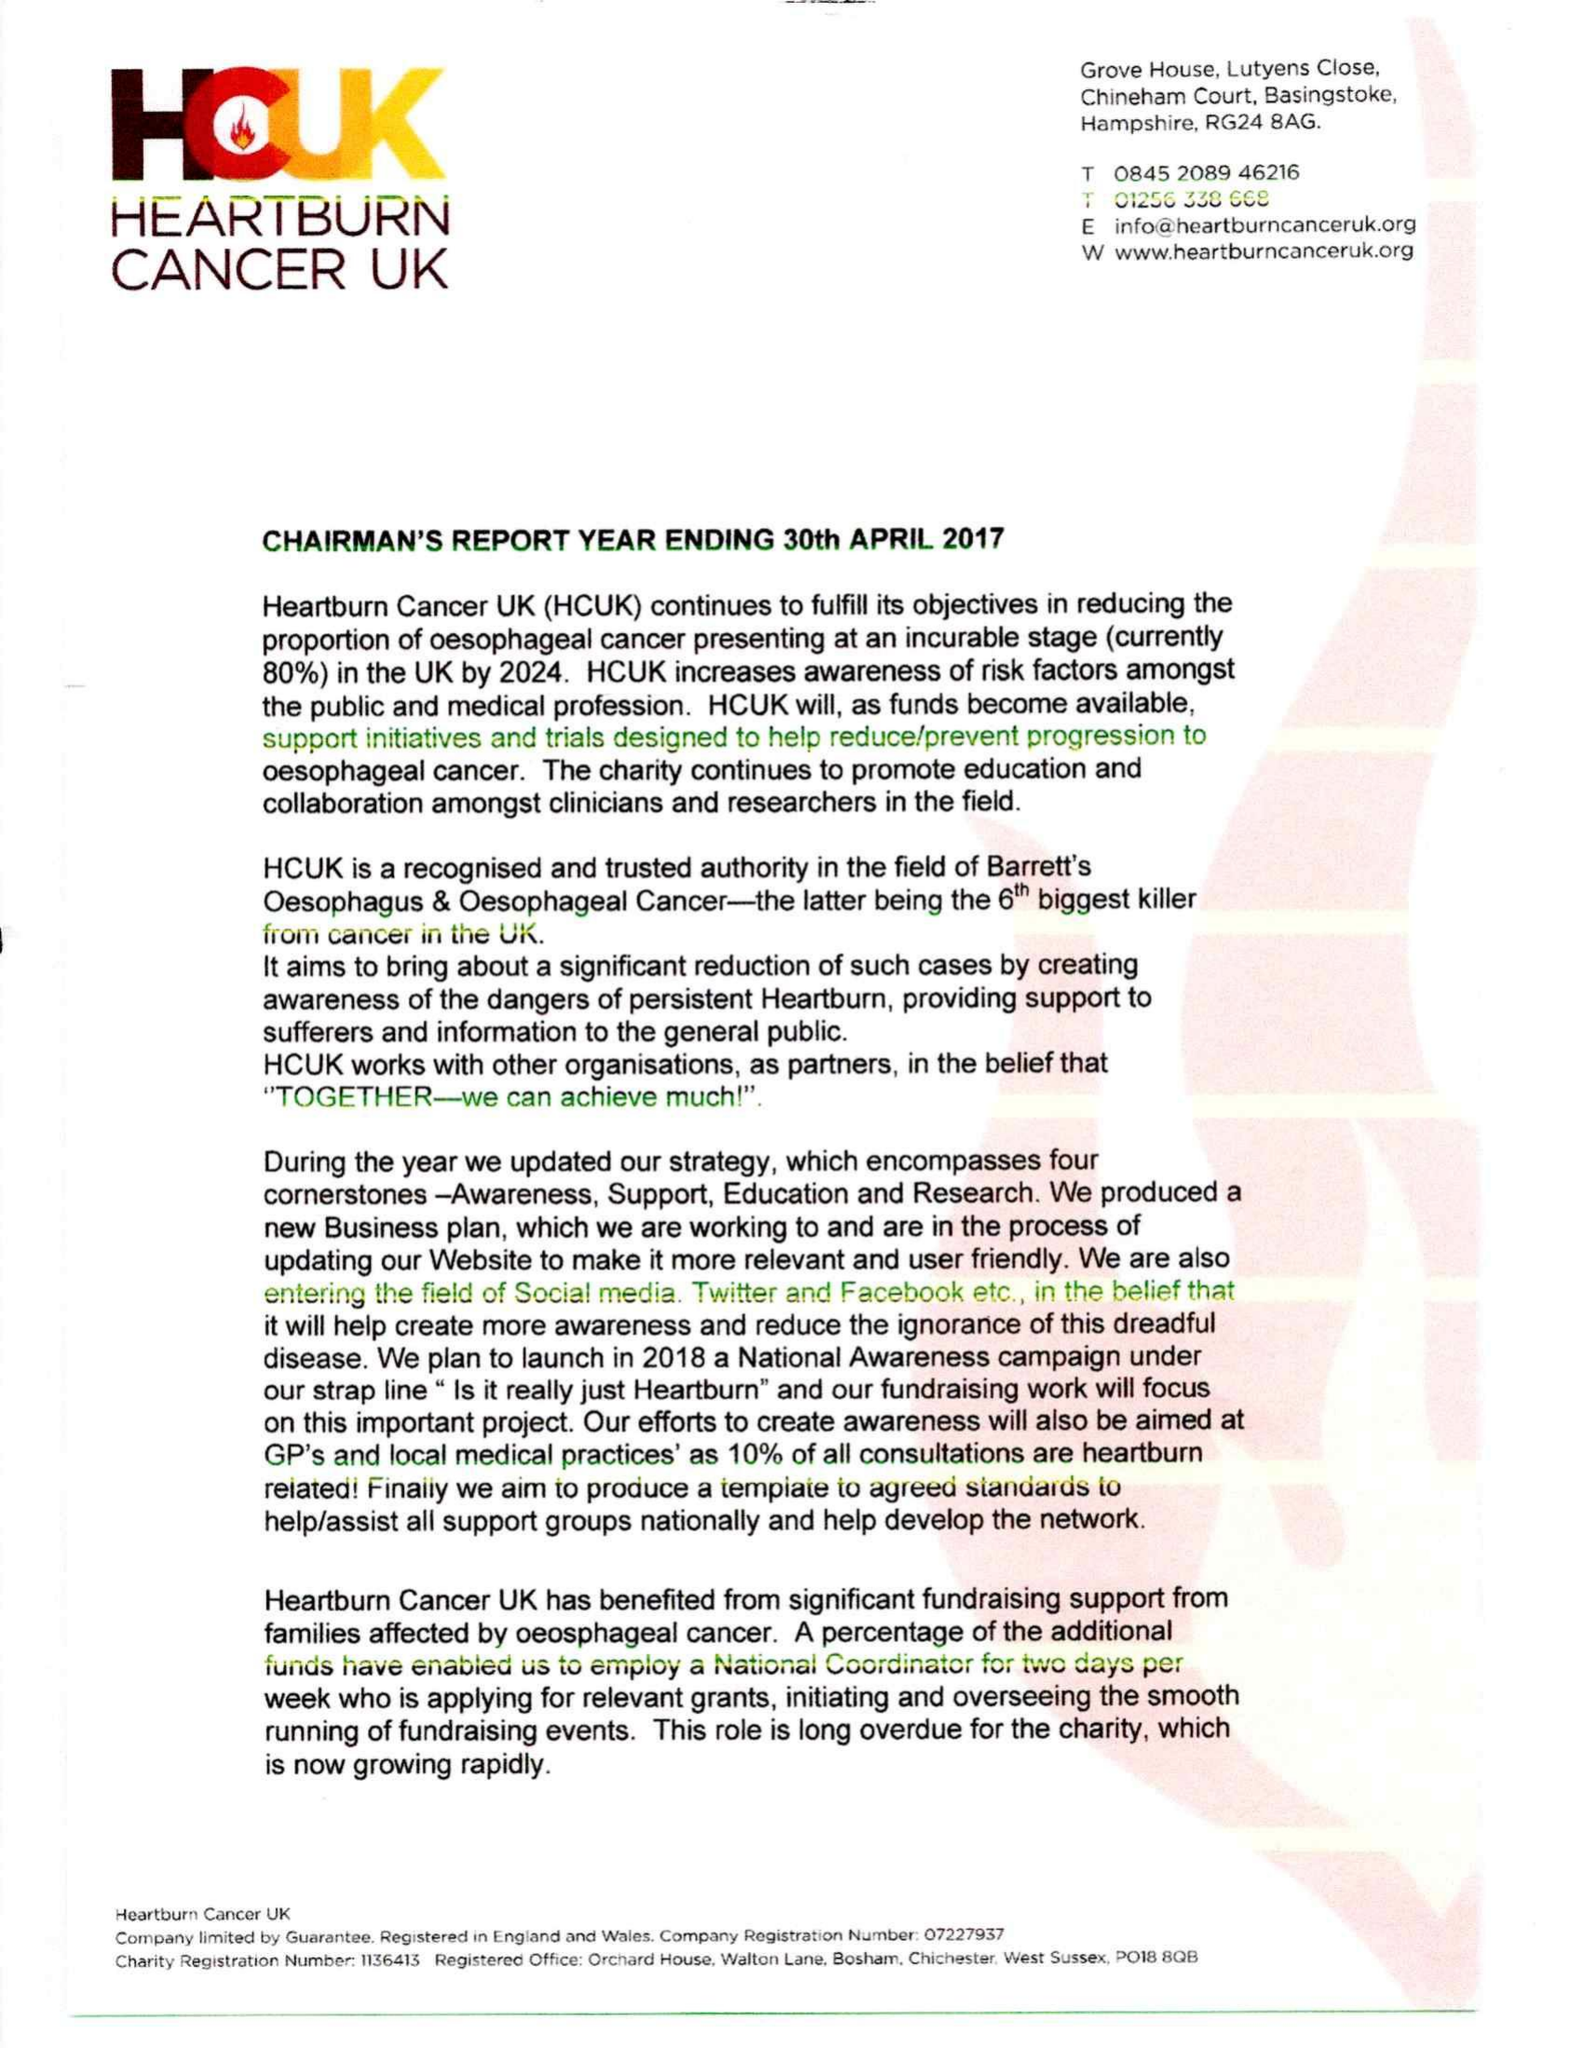What is the value for the income_annually_in_british_pounds?
Answer the question using a single word or phrase. 30484.20 